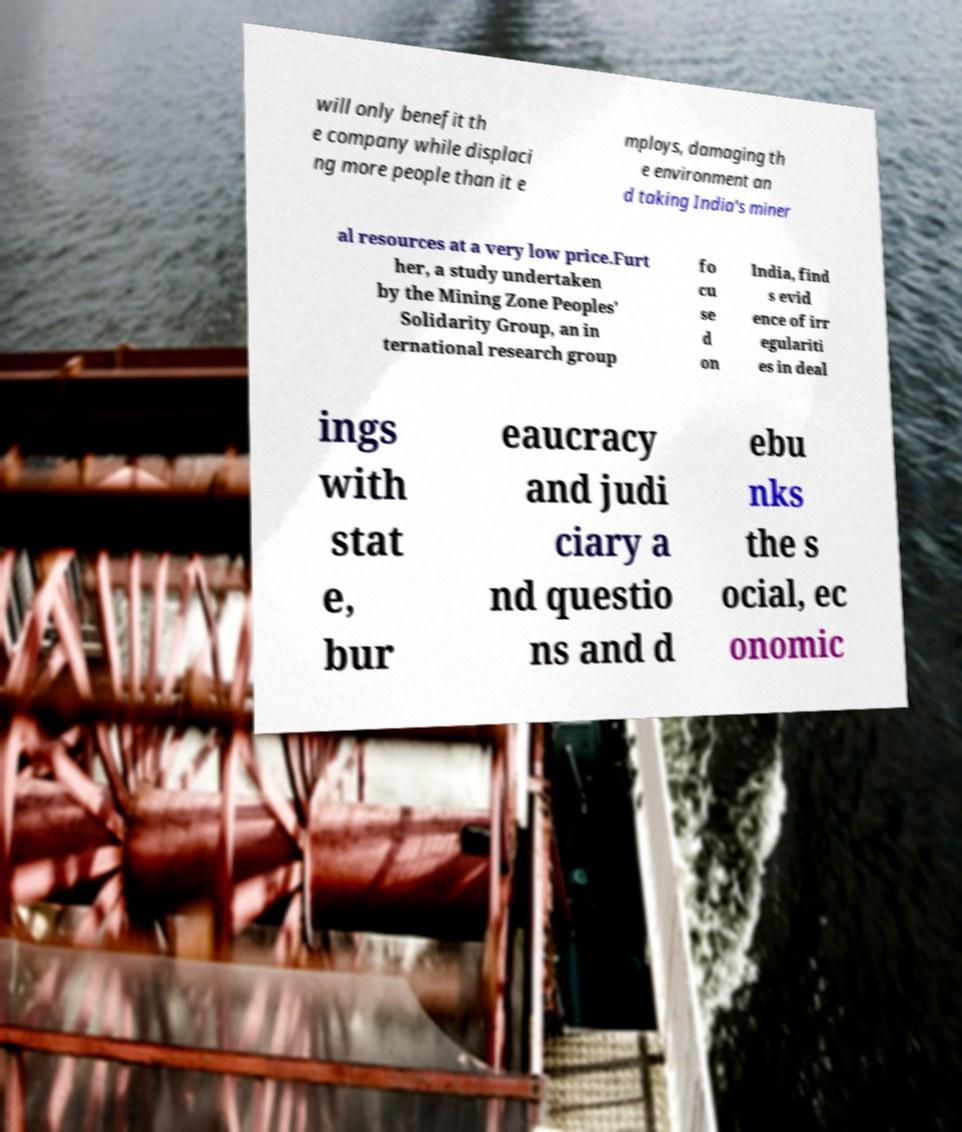I need the written content from this picture converted into text. Can you do that? will only benefit th e company while displaci ng more people than it e mploys, damaging th e environment an d taking India's miner al resources at a very low price.Furt her, a study undertaken by the Mining Zone Peoples' Solidarity Group, an in ternational research group fo cu se d on India, find s evid ence of irr egulariti es in deal ings with stat e, bur eaucracy and judi ciary a nd questio ns and d ebu nks the s ocial, ec onomic 